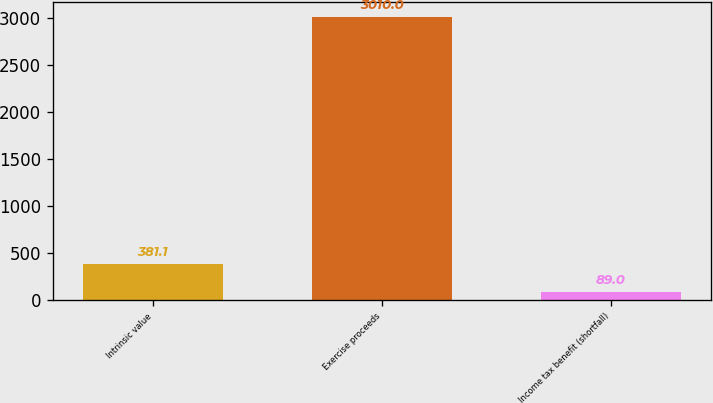Convert chart to OTSL. <chart><loc_0><loc_0><loc_500><loc_500><bar_chart><fcel>Intrinsic value<fcel>Exercise proceeds<fcel>Income tax benefit (shortfall)<nl><fcel>381.1<fcel>3010<fcel>89<nl></chart> 